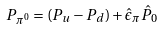Convert formula to latex. <formula><loc_0><loc_0><loc_500><loc_500>P _ { \pi ^ { 0 } } = ( P _ { u } - P _ { d } ) + \hat { \epsilon } _ { \pi } \hat { P } _ { 0 }</formula> 